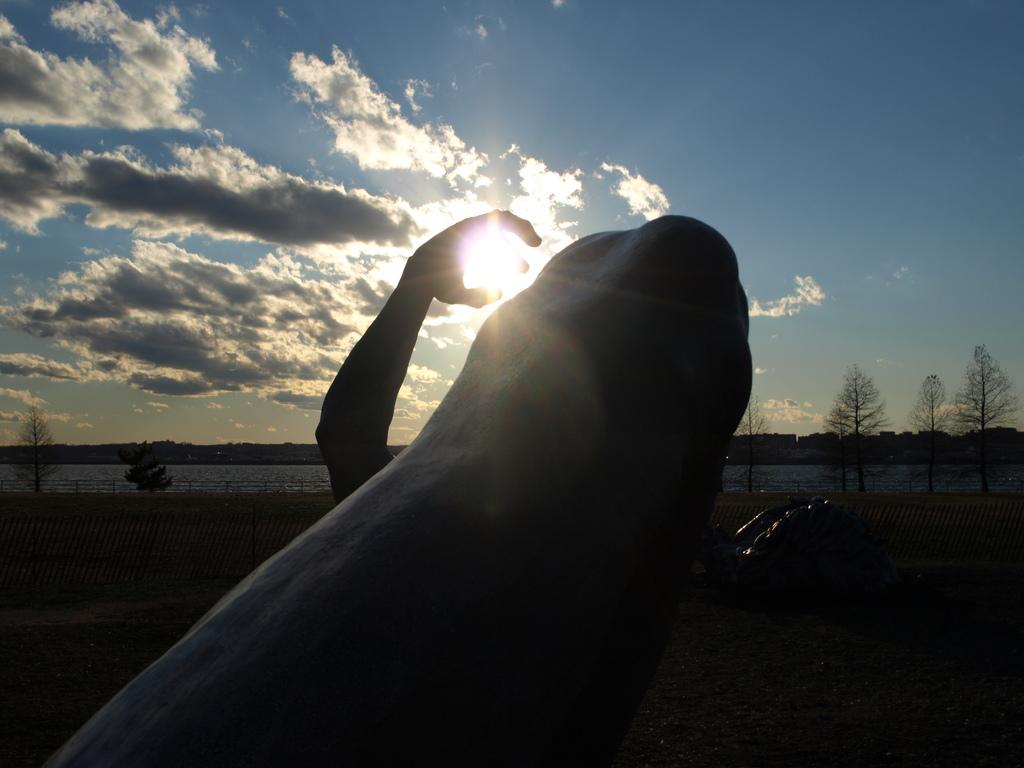What part of a person's body is visible in the image? There is a person's hand visible in the image. What is the hand doing or interacting with in the image? The hand is behind an object. What can be seen in the background of the image? There is fencing, water, trees, and a sunny sky visible in the background of the image. Where is the library located in the image? There is no library present in the image. How many people are in the crowd in the image? There is no crowd present in the image. 